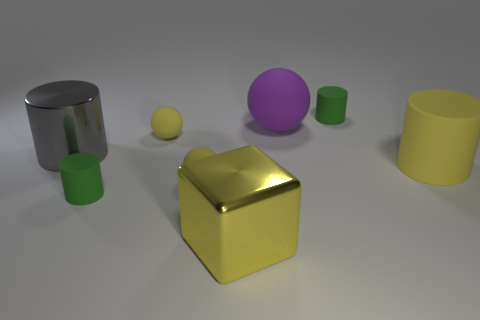Subtract 2 cylinders. How many cylinders are left? 2 Subtract all yellow cylinders. How many cylinders are left? 3 Add 1 tiny brown metal things. How many objects exist? 9 Subtract all purple cylinders. Subtract all cyan balls. How many cylinders are left? 4 Subtract all blocks. How many objects are left? 7 Subtract all big purple rubber balls. Subtract all small yellow matte objects. How many objects are left? 5 Add 2 large yellow things. How many large yellow things are left? 4 Add 4 yellow metallic blocks. How many yellow metallic blocks exist? 5 Subtract 0 red balls. How many objects are left? 8 